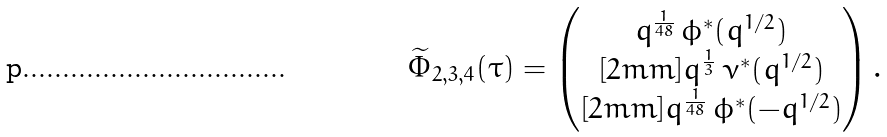Convert formula to latex. <formula><loc_0><loc_0><loc_500><loc_500>\widetilde { \Phi } _ { 2 , 3 , 4 } ( \tau ) = \begin{pmatrix} q ^ { \frac { 1 } { 4 8 } } \, \phi ^ { * } ( q ^ { 1 / 2 } ) \\ [ 2 m m ] q ^ { \frac { 1 } { 3 } } \, \nu ^ { * } ( q ^ { 1 / 2 } ) \\ [ 2 m m ] q ^ { \frac { 1 } { 4 8 } } \, \phi ^ { * } ( - q ^ { 1 / 2 } ) \end{pmatrix} .</formula> 